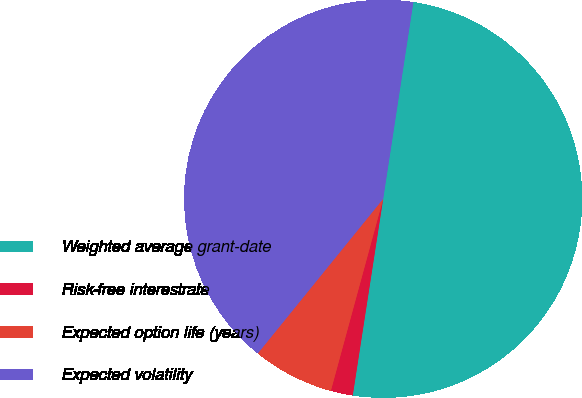<chart> <loc_0><loc_0><loc_500><loc_500><pie_chart><fcel>Weighted average grant-date<fcel>Risk-free interestrate<fcel>Expected option life (years)<fcel>Expected volatility<nl><fcel>50.02%<fcel>1.79%<fcel>6.61%<fcel>41.58%<nl></chart> 